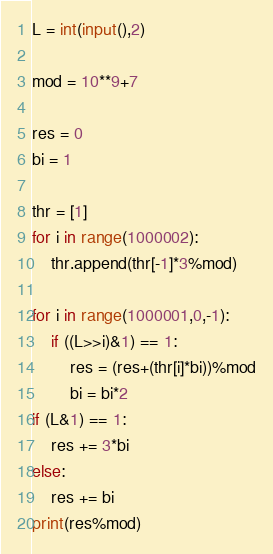<code> <loc_0><loc_0><loc_500><loc_500><_Python_>L = int(input(),2)

mod = 10**9+7

res = 0
bi = 1

thr = [1]
for i in range(1000002):
    thr.append(thr[-1]*3%mod)

for i in range(1000001,0,-1):
    if ((L>>i)&1) == 1:
        res = (res+(thr[i]*bi))%mod
        bi = bi*2
if (L&1) == 1:
    res += 3*bi
else:
    res += bi
print(res%mod)
</code> 